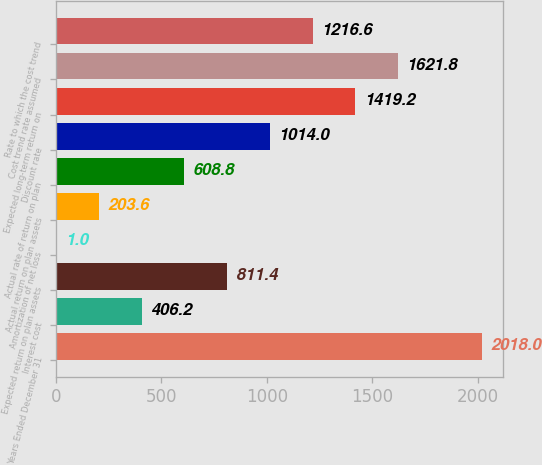Convert chart. <chart><loc_0><loc_0><loc_500><loc_500><bar_chart><fcel>Years Ended December 31<fcel>Interest cost<fcel>Expected return on plan assets<fcel>Amortization of net loss<fcel>Actual return on plan assets<fcel>Actual rate of return on plan<fcel>Discount rate<fcel>Expected long-term return on<fcel>Cost trend rate assumed<fcel>Rate to which the cost trend<nl><fcel>2018<fcel>406.2<fcel>811.4<fcel>1<fcel>203.6<fcel>608.8<fcel>1014<fcel>1419.2<fcel>1621.8<fcel>1216.6<nl></chart> 